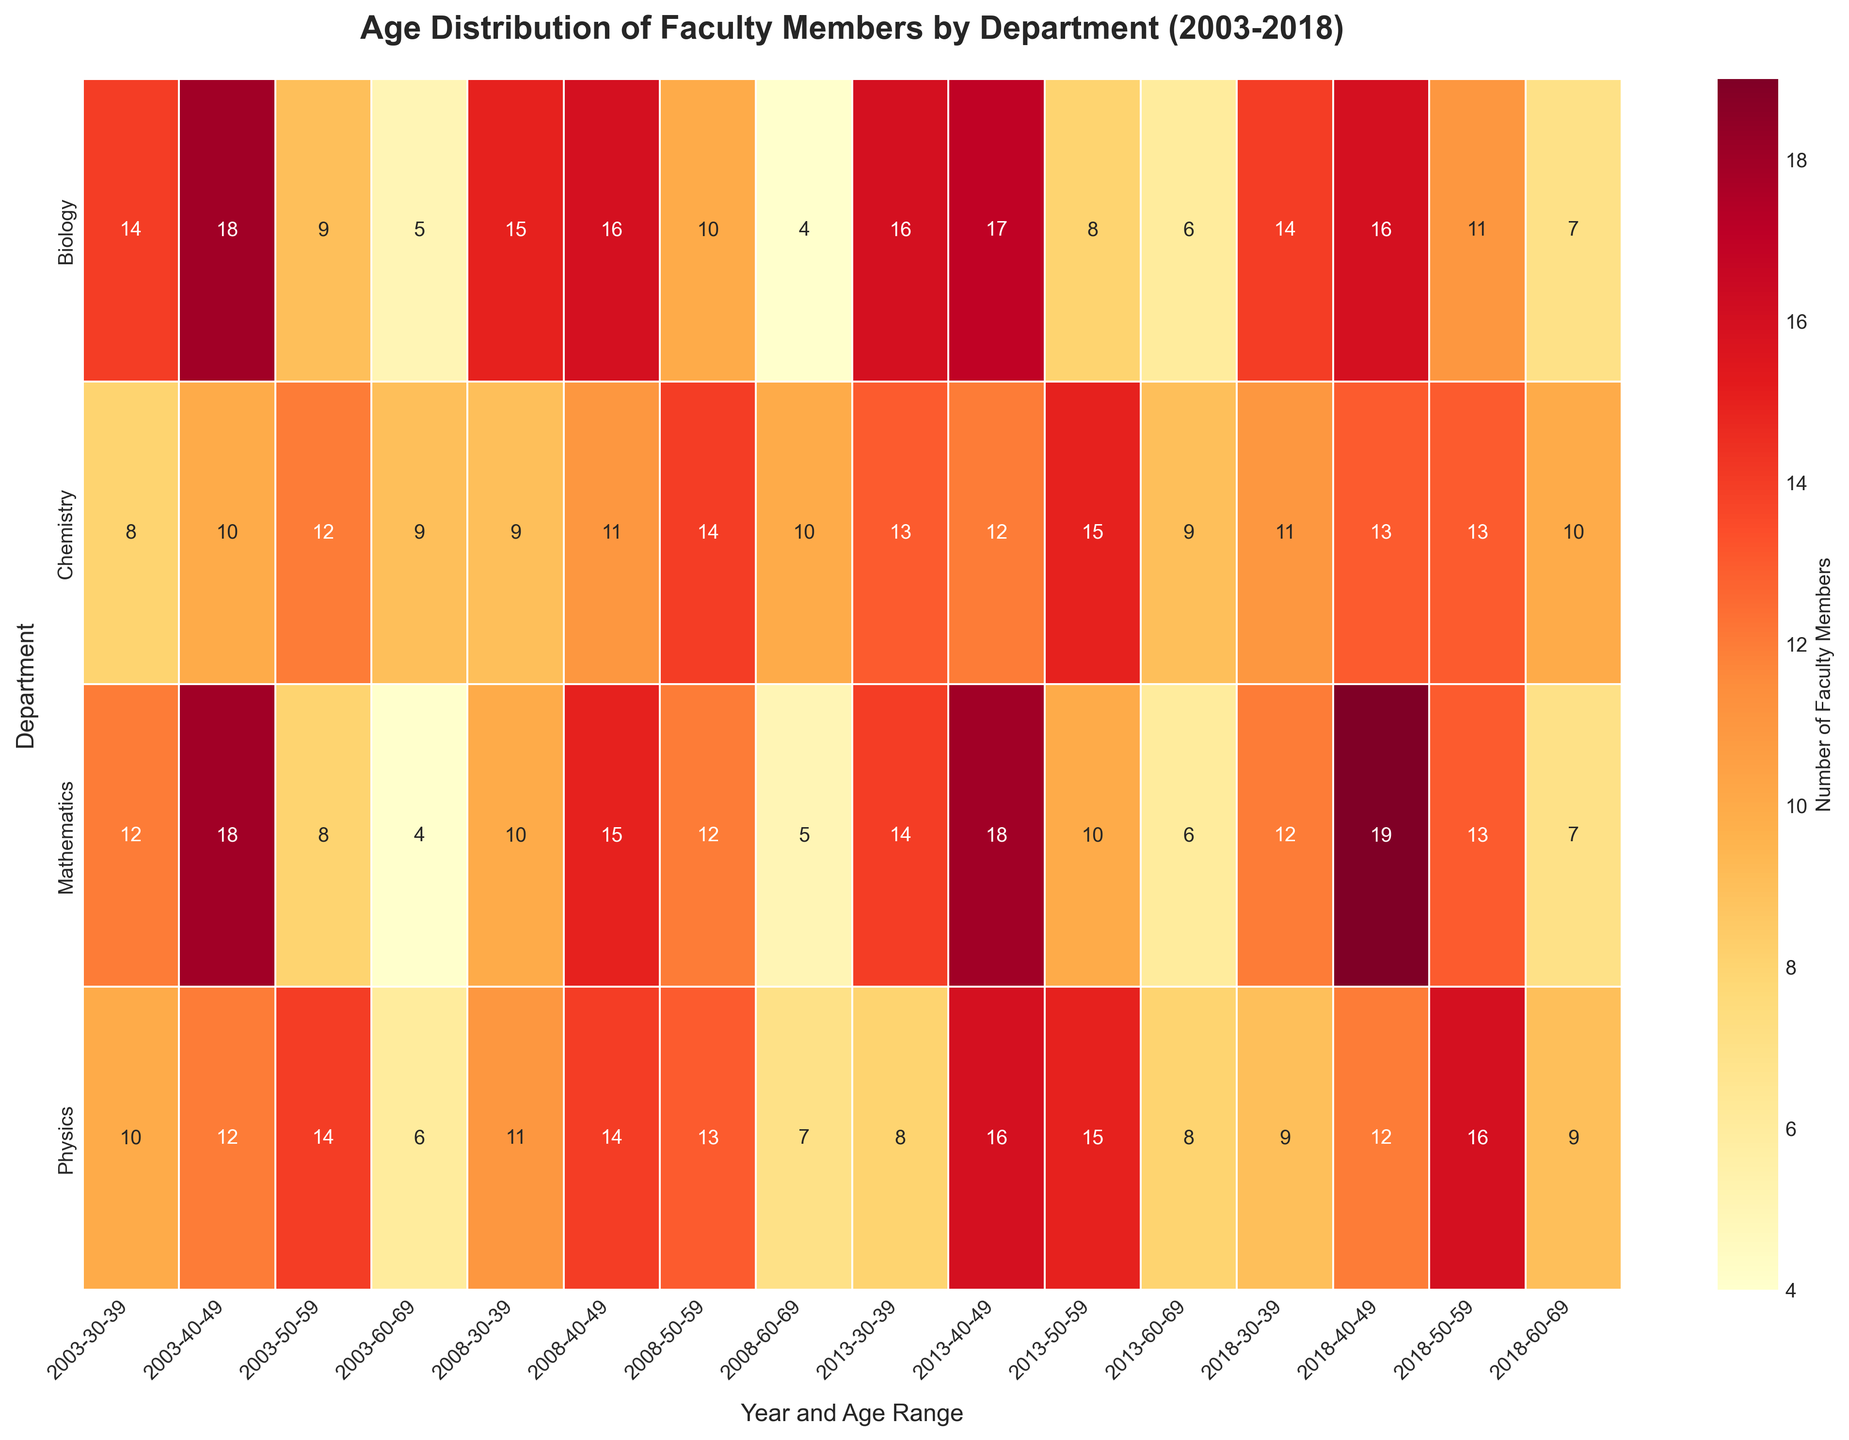What is the title of the heatmap? The title of the heatmap is typically placed at the top of the figure. It provides a clear summary of what the heatmap represents.
Answer: Age Distribution of Faculty Members by Department (2003-2018) Which department has the highest number of faculty members in the age range 40-49 in 2018? Observe the color intensity in the 2018 column under the age range 40-49 for each department. The higher the number, the darker (or more intense) the color in that cell.
Answer: Mathematics What is the trend in the number of Mathematics faculty members aged 60-69 from 2003 to 2018? By following the cells corresponding to the Mathematics department and the age range 60-69 across the years 2003, 2008, 2013, and 2018, you can see the changes in their numbers.
Answer: Increasing Which age range has the most significant variation in faculty numbers within the Chemistry department over the years? Compare the color intensities for each age range within the Chemistry department. The range with the most considerable variation would show the largest differences in color intensities across the years.
Answer: 30-39 Between Biology and Physics, which department had more faculty members aged 50-59 in 2013? Compare the cells for Biology and Physics in the 2013 column under the age range 50-59. The department with the darker (or more intense) color has more faculty members.
Answer: Physics How does the number of faculty members aged 30-39 in the Mathematics department in 2018 compare to the number in 2003? Look at the cells for Mathematics in the age range 30-39 for the years 2003 and 2018. Compare the numbers or intensity of the cells directly.
Answer: Slightly lower in 2018 What is the sum of faculty members in the 50-59 age range for all departments in 2008? Sum the numbers in the 50-59 age range for the year 2008 across Mathematics, Physics, Chemistry, and Biology departments.
Answer: 49 Which age range consistently has the lowest number of faculty members across all departments and years? Scan through the heatmap for the lightest (least intense) colors across all departments and years.
Answer: 60-69 Is there an increasing or decreasing trend in the number of faculty members in the 40-49 age range in the Biology department from 2003 to 2018? Follow the cells corresponding to Biology and the age range 40-49 from 2003 to 2018 to observe the trends in numbers.
Answer: Decreasing What's the difference in the number of Physics faculty members aged 30-39 between 2003 and 2013? Subtract the number of Physics faculty members aged 30-39 in 2013 from the number in 2003.
Answer: 2 less 